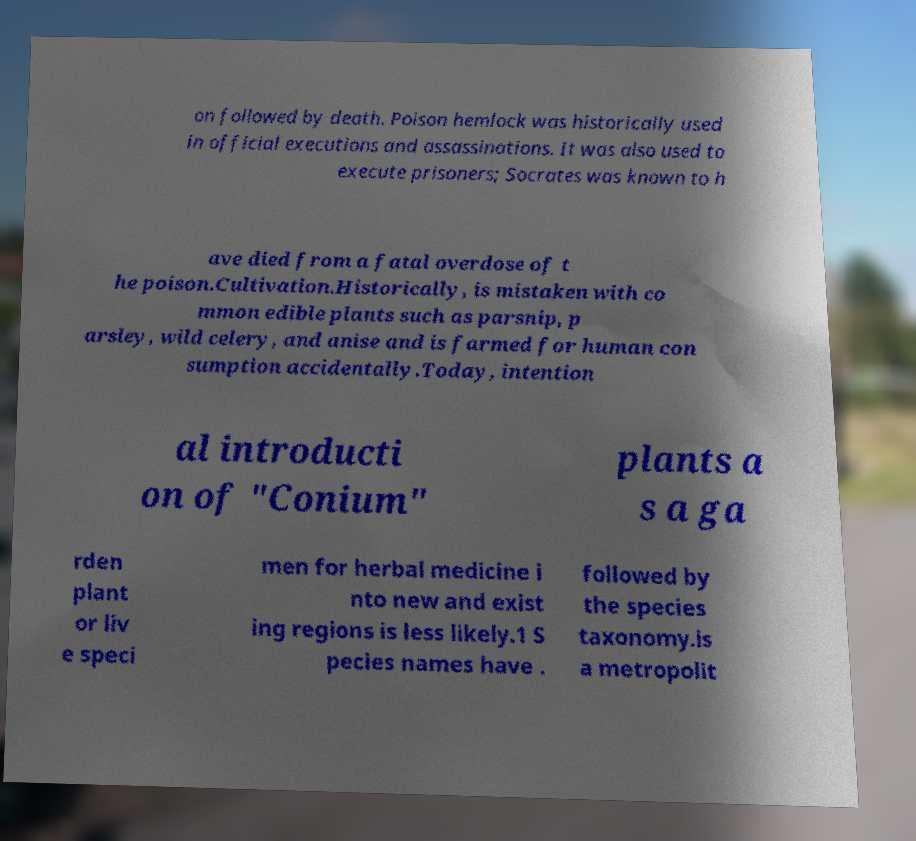What messages or text are displayed in this image? I need them in a readable, typed format. on followed by death. Poison hemlock was historically used in official executions and assassinations. It was also used to execute prisoners; Socrates was known to h ave died from a fatal overdose of t he poison.Cultivation.Historically, is mistaken with co mmon edible plants such as parsnip, p arsley, wild celery, and anise and is farmed for human con sumption accidentally.Today, intention al introducti on of "Conium" plants a s a ga rden plant or liv e speci men for herbal medicine i nto new and exist ing regions is less likely.1 S pecies names have . followed by the species taxonomy.is a metropolit 